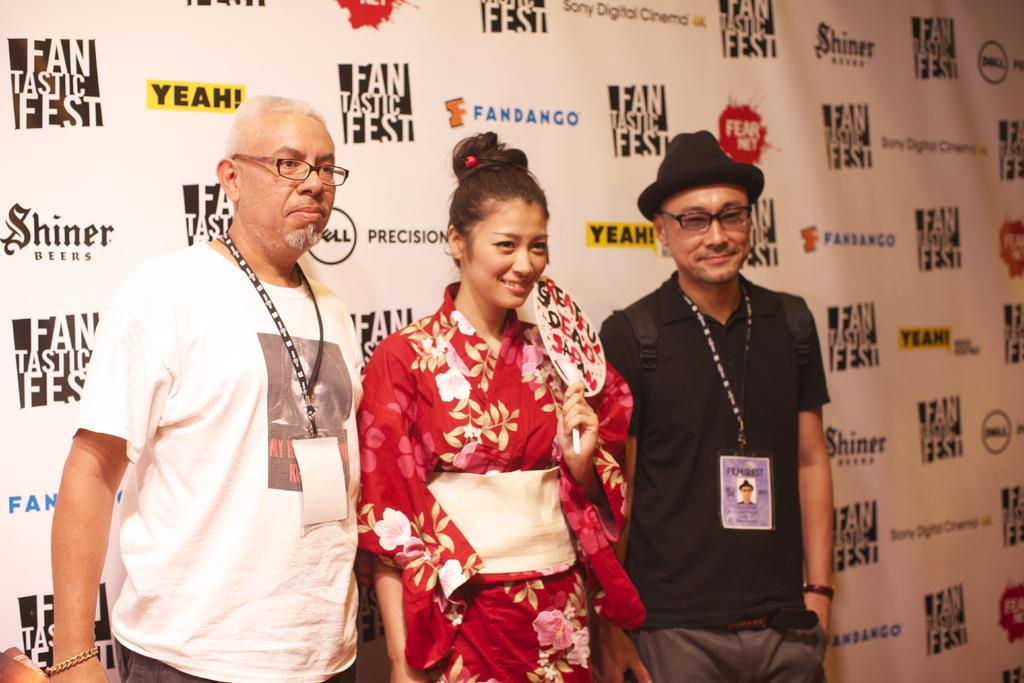How many people are in the image? There are three people in the image. What are the people doing in the image? The people are standing and posing for a photo. What can be seen in the background of the image? There is a banner in the background of the image. What is written on the banner? The banner has the names of different sponsors. What type of shirt is the camera wearing in the image? There is no camera present in the image, and therefore no shirt for it to wear. 